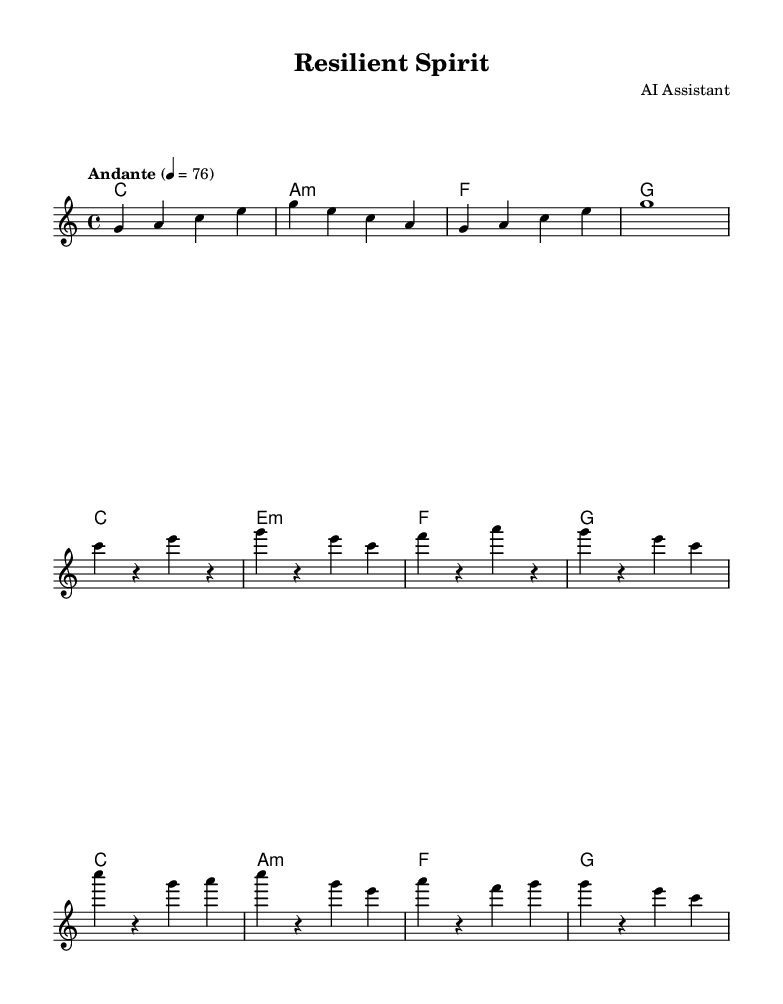What is the key signature of this music? The key signature is indicated by the key signature at the beginning of the score, which shows no sharps or flats, denoting C major.
Answer: C major What is the time signature of this composition? The time signature, shown at the beginning of the score, is 4/4, indicating four beats per measure.
Answer: 4/4 What tempo marking is given for this piece? The tempo is written above the staff with a note saying "Andante" followed by a metronomic indication of 76 beats per minute.
Answer: Andante, 76 How many measures are in the chorus section? By counting the measures specifically labeled as part of the chorus section within the score, there are four measures total in that section.
Answer: 4 What is the first chord in the piece? The first chord is presented at the beginning of the score under the chord names, and it is C major, denoted by 'c' in the chord mode.
Answer: C Which voice section is the melody written for? The melody is specifically written for the voice section labeled as "melody" in the score.
Answer: melody What is the last note in the melody? The last note of the melody is indicated in the final measure, which shows a whole note held out as G.
Answer: G 